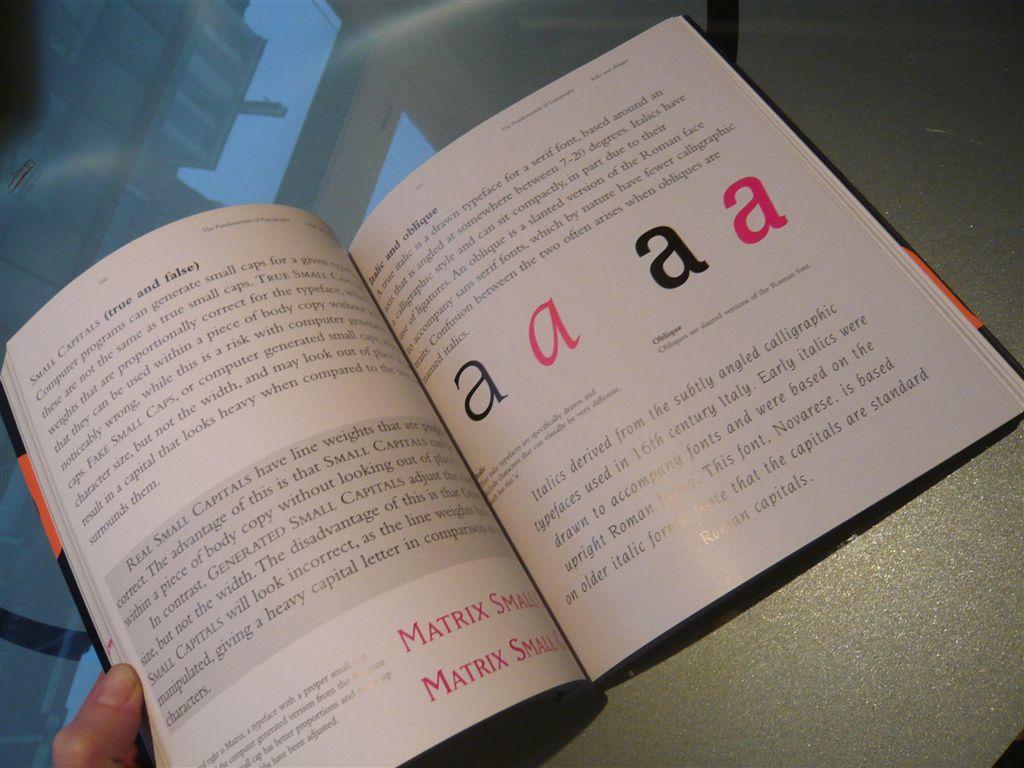How many red a's are there?
Offer a very short reply. 2. 